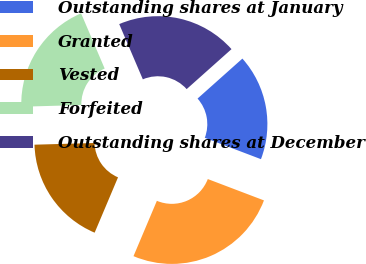Convert chart. <chart><loc_0><loc_0><loc_500><loc_500><pie_chart><fcel>Outstanding shares at January<fcel>Granted<fcel>Vested<fcel>Forfeited<fcel>Outstanding shares at December<nl><fcel>17.37%<fcel>25.58%<fcel>18.19%<fcel>19.02%<fcel>19.84%<nl></chart> 